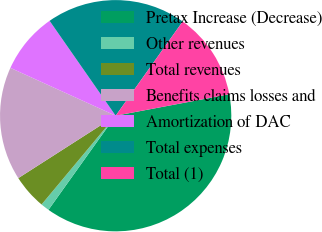Convert chart. <chart><loc_0><loc_0><loc_500><loc_500><pie_chart><fcel>Pretax Increase (Decrease)<fcel>Other revenues<fcel>Total revenues<fcel>Benefits claims losses and<fcel>Amortization of DAC<fcel>Total expenses<fcel>Total (1)<nl><fcel>37.84%<fcel>1.2%<fcel>4.86%<fcel>15.86%<fcel>8.53%<fcel>19.52%<fcel>12.19%<nl></chart> 